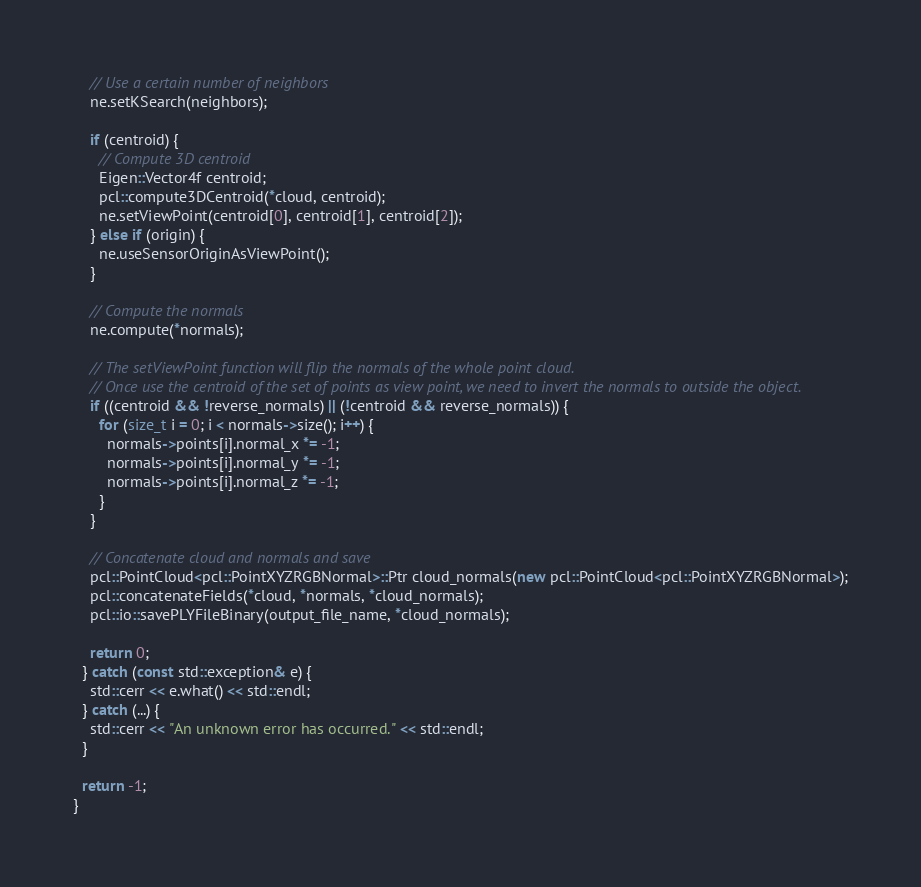Convert code to text. <code><loc_0><loc_0><loc_500><loc_500><_C++_>
    // Use a certain number of neighbors
    ne.setKSearch(neighbors);

    if (centroid) {
      // Compute 3D centroid
      Eigen::Vector4f centroid;
      pcl::compute3DCentroid(*cloud, centroid);
      ne.setViewPoint(centroid[0], centroid[1], centroid[2]);
    } else if (origin) {
      ne.useSensorOriginAsViewPoint();
    }

    // Compute the normals
    ne.compute(*normals);

    // The setViewPoint function will flip the normals of the whole point cloud.
    // Once use the centroid of the set of points as view point, we need to invert the normals to outside the object.
    if ((centroid && !reverse_normals) || (!centroid && reverse_normals)) {
      for (size_t i = 0; i < normals->size(); i++) {
        normals->points[i].normal_x *= -1;
        normals->points[i].normal_y *= -1;
        normals->points[i].normal_z *= -1;
      }
    }

    // Concatenate cloud and normals and save
    pcl::PointCloud<pcl::PointXYZRGBNormal>::Ptr cloud_normals(new pcl::PointCloud<pcl::PointXYZRGBNormal>);
    pcl::concatenateFields(*cloud, *normals, *cloud_normals);
    pcl::io::savePLYFileBinary(output_file_name, *cloud_normals);

    return 0;
  } catch (const std::exception& e) {
    std::cerr << e.what() << std::endl;
  } catch (...) {
    std::cerr << "An unknown error has occurred." << std::endl;
  }

  return -1;
}
</code> 